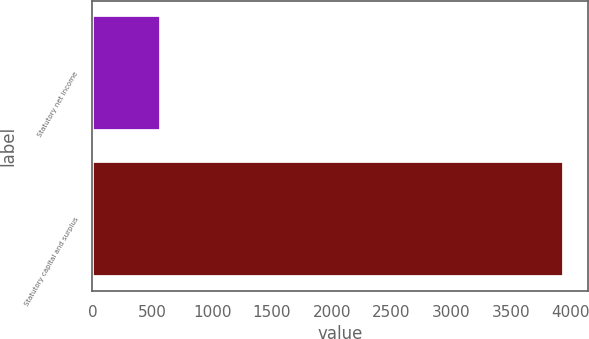Convert chart to OTSL. <chart><loc_0><loc_0><loc_500><loc_500><bar_chart><fcel>Statutory net income<fcel>Statutory capital and surplus<nl><fcel>576.1<fcel>3944.3<nl></chart> 